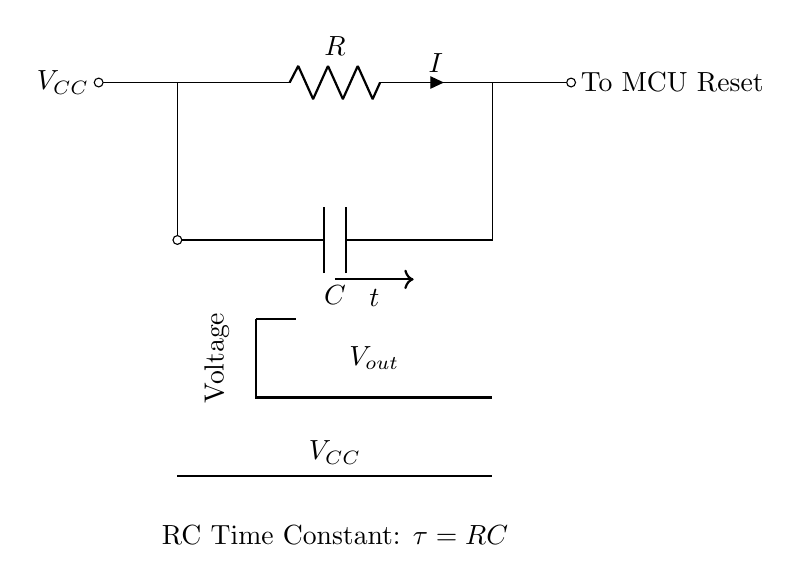What is the type of components used in this circuit? The circuit contains a resistor and a capacitor, which are the primary components used to create the RC time delay.
Answer: Resistor and Capacitor What does the symbol VCC represent in the circuit? VCC denotes the supply voltage for the circuit, which provides the necessary power for operation of the connected components and microcontroller.
Answer: Supply Voltage What is the function of the capacitor in this circuit? The capacitor stores charge and helps to create a time delay for the reset signal, allowing the microcontroller to power on and stabilize before executing any instructions.
Answer: Time Delay How is the current labeled in the circuit? The current is labeled as "I" in the circuit diagram, indicating the flow of charge through the resistor.
Answer: I What is the equation for the RC time constant shown in the diagram? The time constant τ is defined as the product of the resistance (R) and capacitance (C) in the circuit, which determines how quickly the voltage across the capacitor rises to a certain level when energized.
Answer: τ = RC What happens to the output voltage (Vout) during power-on reset? During the power-on reset, Vout will initially be low and then rise exponentially towards VCC, following the RC time constant, until the microcontroller reset condition is satisfied.
Answer: Low to VCC How does changing the resistance value affect the circuit? Increasing the resistance value would increase the time constant τ, leading to a longer delay for Vout to rise to a specific voltage threshold needed to release the reset on the microcontroller.
Answer: Longer Delay 